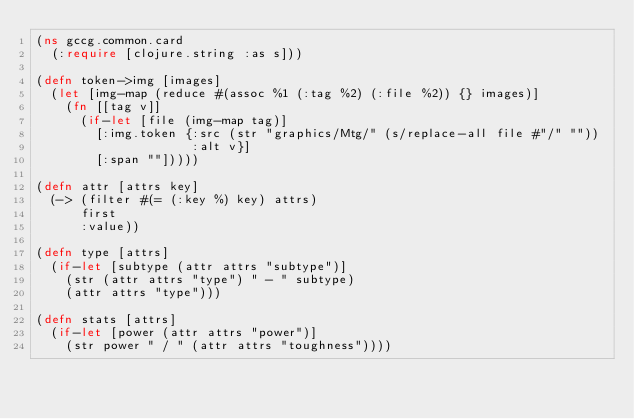Convert code to text. <code><loc_0><loc_0><loc_500><loc_500><_Clojure_>(ns gccg.common.card
  (:require [clojure.string :as s]))

(defn token->img [images]
  (let [img-map (reduce #(assoc %1 (:tag %2) (:file %2)) {} images)]
    (fn [[tag v]]
      (if-let [file (img-map tag)]
        [:img.token {:src (str "graphics/Mtg/" (s/replace-all file #"/" ""))
                     :alt v}]
        [:span ""]))))

(defn attr [attrs key]
  (-> (filter #(= (:key %) key) attrs)
      first
      :value))

(defn type [attrs]
  (if-let [subtype (attr attrs "subtype")]
    (str (attr attrs "type") " - " subtype)
    (attr attrs "type")))

(defn stats [attrs]
  (if-let [power (attr attrs "power")]
    (str power " / " (attr attrs "toughness"))))
</code> 